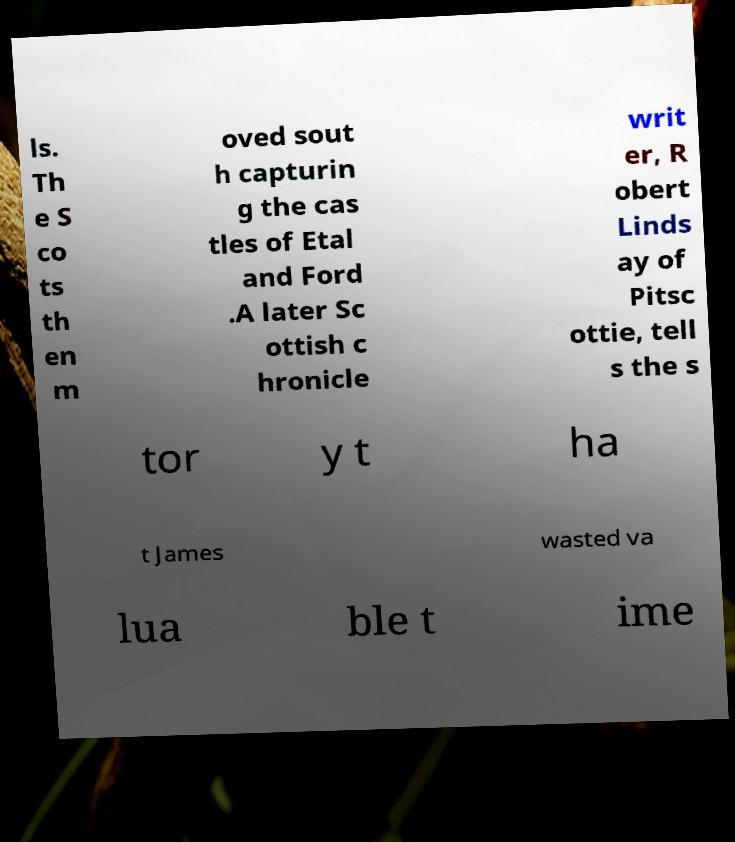Could you extract and type out the text from this image? ls. Th e S co ts th en m oved sout h capturin g the cas tles of Etal and Ford .A later Sc ottish c hronicle writ er, R obert Linds ay of Pitsc ottie, tell s the s tor y t ha t James wasted va lua ble t ime 